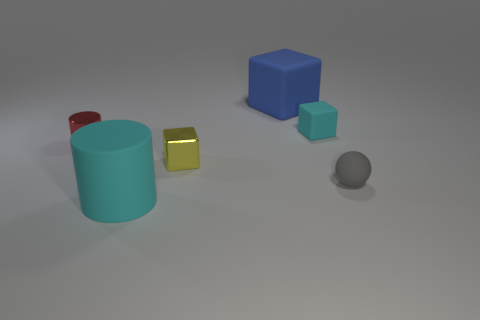Subtract all rubber cubes. How many cubes are left? 1 Add 2 yellow metallic objects. How many objects exist? 8 Subtract all spheres. How many objects are left? 5 Subtract all brown balls. Subtract all yellow cylinders. How many balls are left? 1 Subtract all yellow cubes. How many red cylinders are left? 1 Subtract all rubber blocks. Subtract all small red metal cylinders. How many objects are left? 3 Add 5 small gray rubber things. How many small gray rubber things are left? 6 Add 1 yellow metallic things. How many yellow metallic things exist? 2 Subtract all red cylinders. How many cylinders are left? 1 Subtract 0 brown cylinders. How many objects are left? 6 